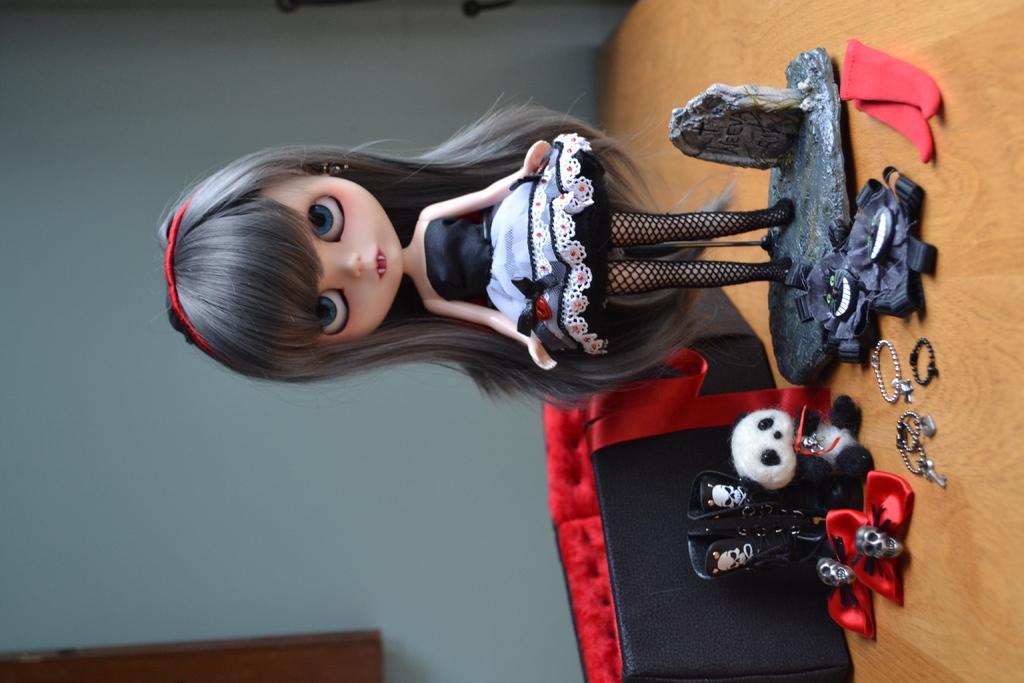Please provide a concise description of this image. In this picture we can see a doll in the middle, there are toys, a bag and a ring on the right side, in the background we can see a wall. 